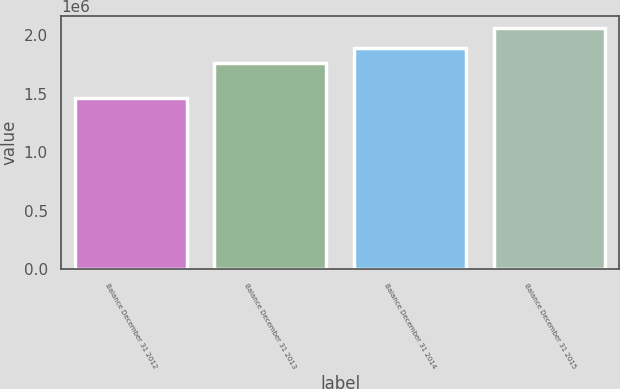Convert chart to OTSL. <chart><loc_0><loc_0><loc_500><loc_500><bar_chart><fcel>Balance December 31 2012<fcel>Balance December 31 2013<fcel>Balance December 31 2014<fcel>Balance December 31 2015<nl><fcel>1.46736e+06<fcel>1.76317e+06<fcel>1.89467e+06<fcel>2.05885e+06<nl></chart> 